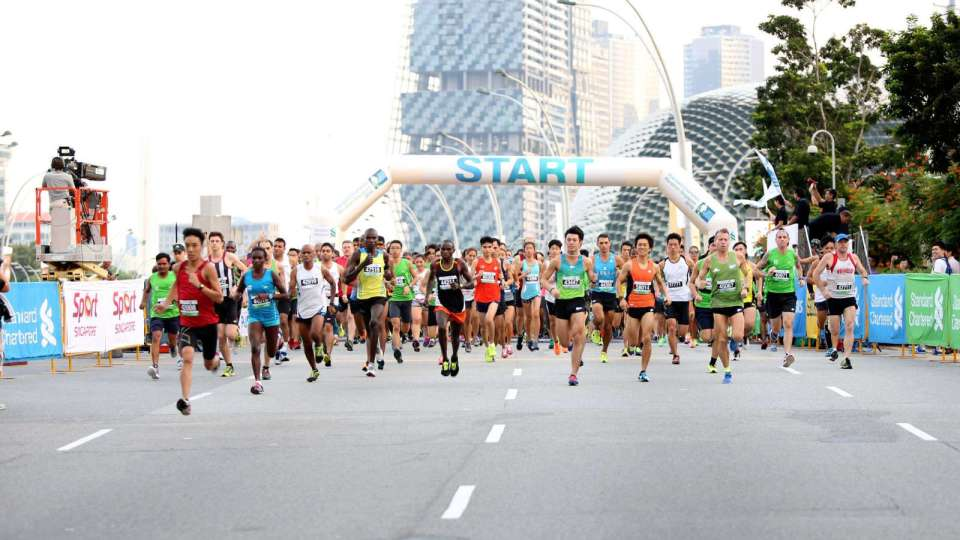Is there an element that stands out or draws the viewer's focus in this image? The image prominently features the 'START' banner, positioned centrally and elevated above the runners, naturally drawing the viewer’s attention initially. The bustling mass of runners in varied, colorful attire further amplifies this focal point, accentuating the beginning of a significant event. What might be the significance of this race based on common knowledge about running events? The significance of this race could range from a local marathon aimed at fostering community spirit and promoting fitness to an international competition attracting elite athletes. Commonly, such events also serve as platforms for charitable causes or celebrations of athletic participation and perseverance. 